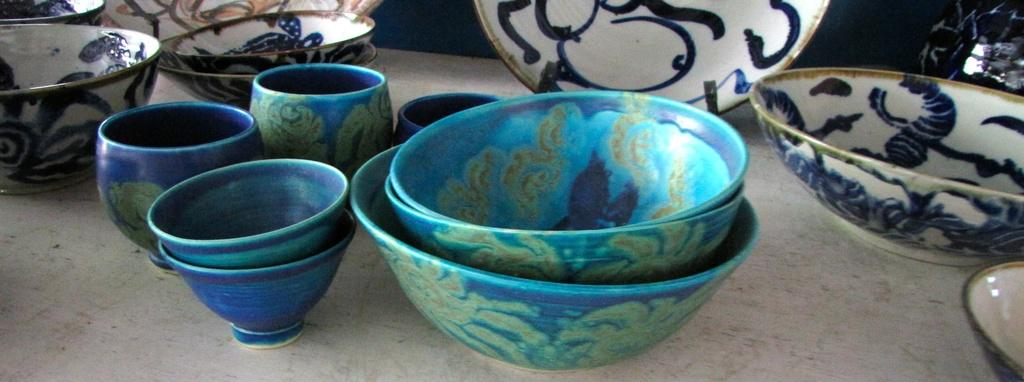What type of dishware is visible in the image? There are bowls and plates in the image. Where are the bowls and plates located? The bowls and plates are on a surface. What type of station can be seen in the image? There is no station present in the image; it features bowls and plates on a surface. What type of land is visible in the image? The image does not depict any land; it only shows bowls and plates on a surface. 